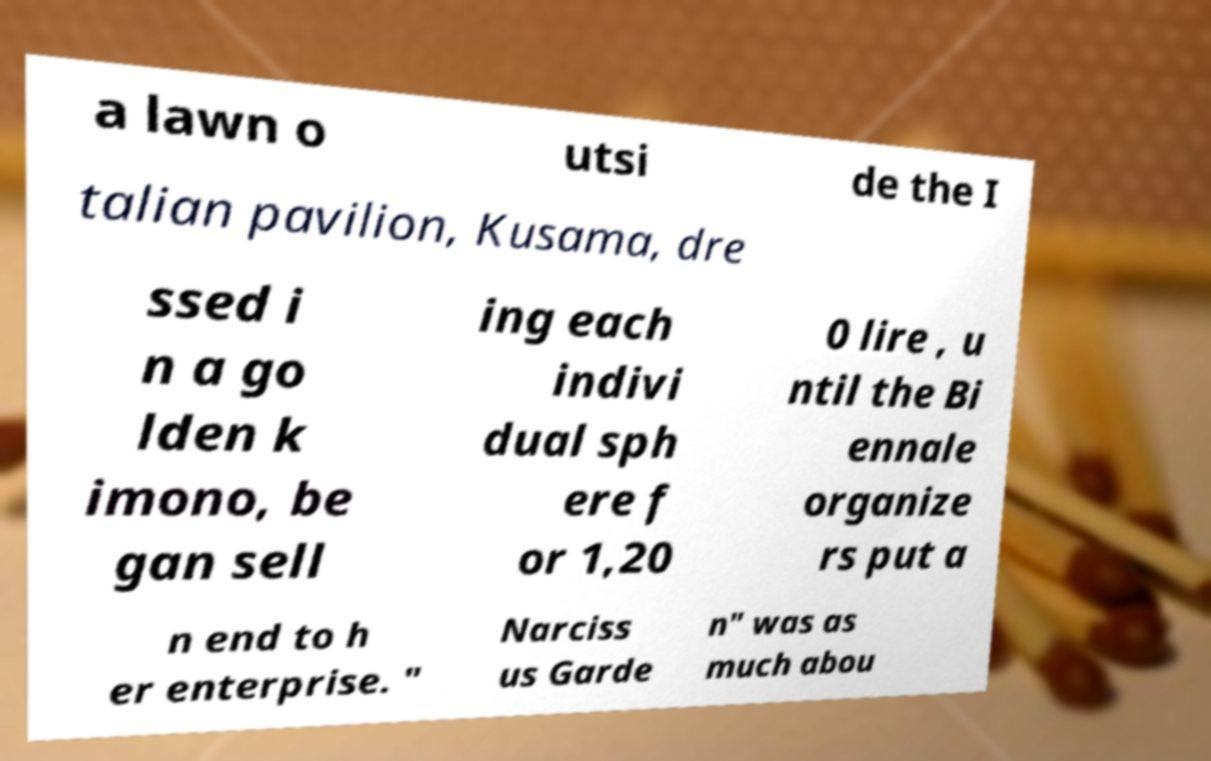What messages or text are displayed in this image? I need them in a readable, typed format. a lawn o utsi de the I talian pavilion, Kusama, dre ssed i n a go lden k imono, be gan sell ing each indivi dual sph ere f or 1,20 0 lire , u ntil the Bi ennale organize rs put a n end to h er enterprise. " Narciss us Garde n" was as much abou 